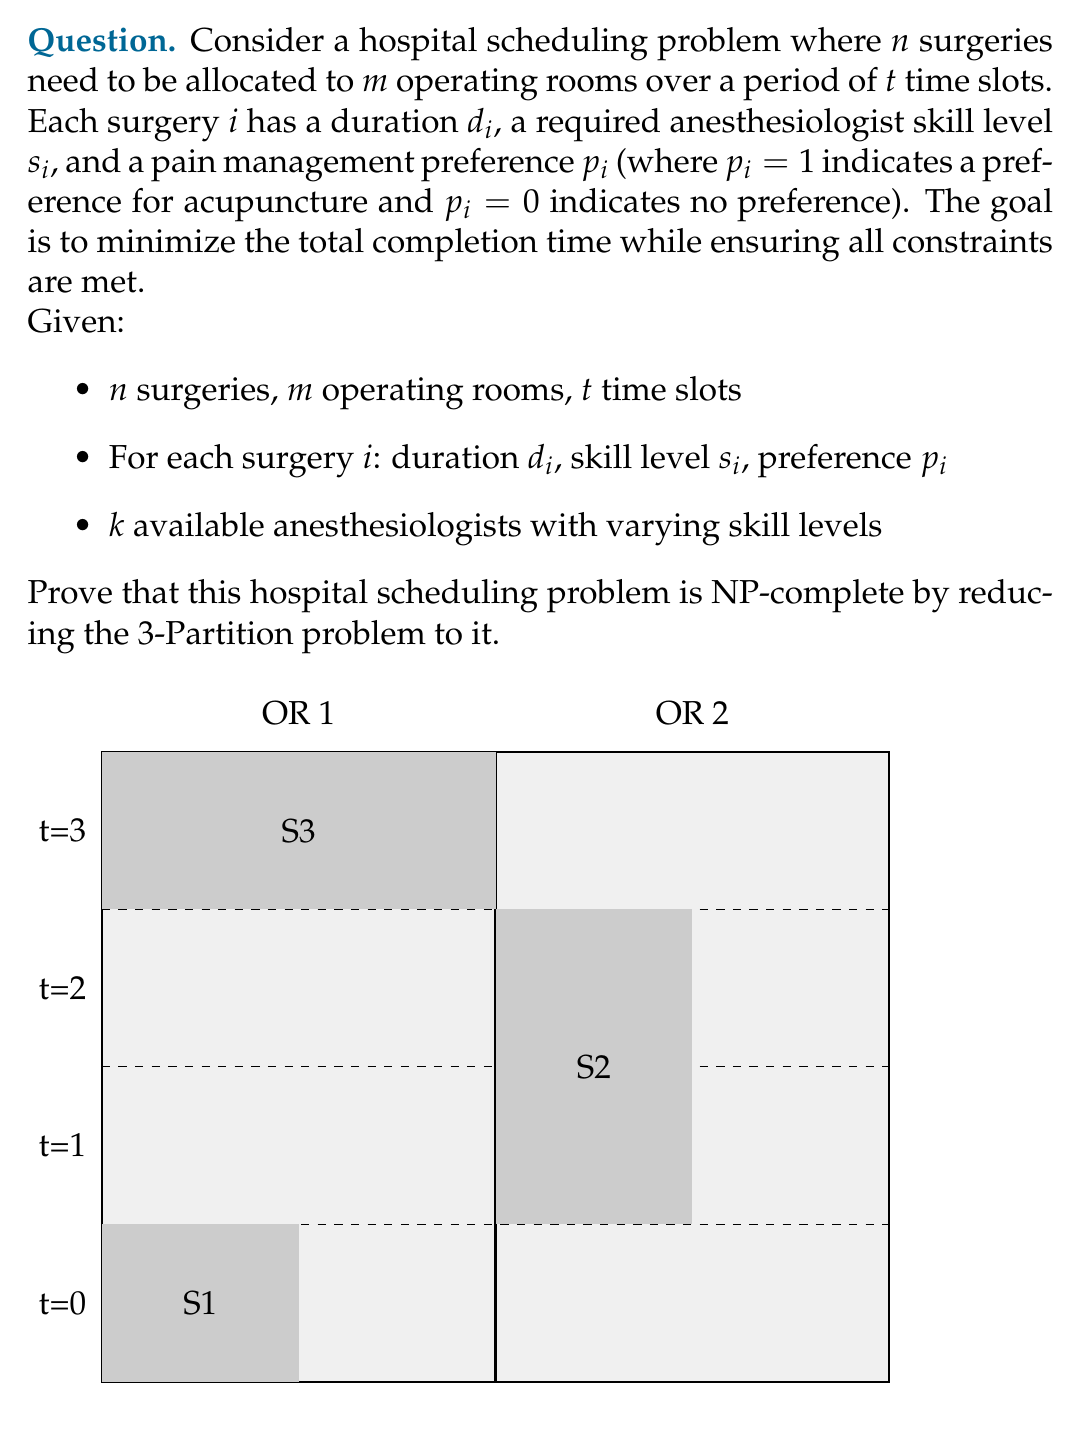Can you solve this math problem? To prove that the hospital scheduling problem is NP-complete, we need to show that:
1. It is in NP
2. It is at least as hard as a known NP-complete problem (in this case, 3-Partition)

Step 1: Show the problem is in NP
- A solution to the problem can be verified in polynomial time by checking:
  a) All surgeries are scheduled
  b) No overlaps in operating room usage
  c) Anesthesiologist skill levels match surgery requirements
  d) Pain management preferences are respected
  e) Total completion time is calculated correctly

Step 2: Reduce 3-Partition to the hospital scheduling problem

The 3-Partition problem:
Given a set $A$ of $3m$ positive integers, can $A$ be partitioned into $m$ subsets $S_1, S_2, ..., S_m$ such that the sum of the numbers in each subset is equal?

Reduction:
1. Create $m$ operating rooms
2. Set $t = B$, where $B$ is the target sum for each partition in 3-Partition
3. For each integer $a_i$ in set $A$:
   - Create a surgery with duration $d_i = a_i$
   - Set skill level $s_i = 1$ and preference $p_i = 0$
4. Create one anesthesiologist with skill level 1

Now, solving the hospital scheduling problem is equivalent to solving 3-Partition:
- If a valid schedule exists, it corresponds to a valid 3-Partition
- If no valid schedule exists, there is no solution to 3-Partition

The reduction is polynomial-time, as we create $O(n)$ surgeries and $O(m)$ operating rooms.

Since 3-Partition is NP-complete and we have reduced it to our hospital scheduling problem, our problem is at least as hard as 3-Partition. Combined with the fact that it's in NP, we can conclude that the hospital scheduling problem is NP-complete.
Answer: NP-complete 